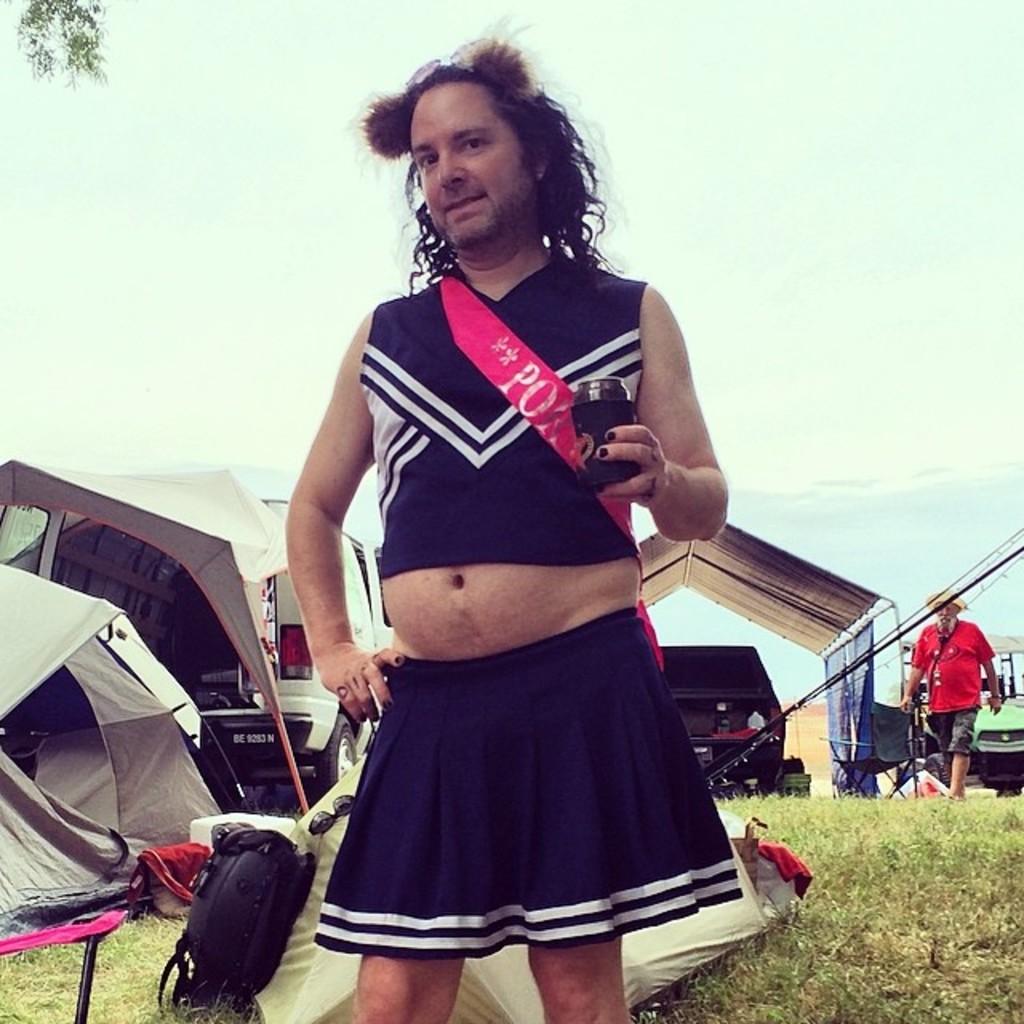What letters are on his sash?
Give a very brief answer. Po. 